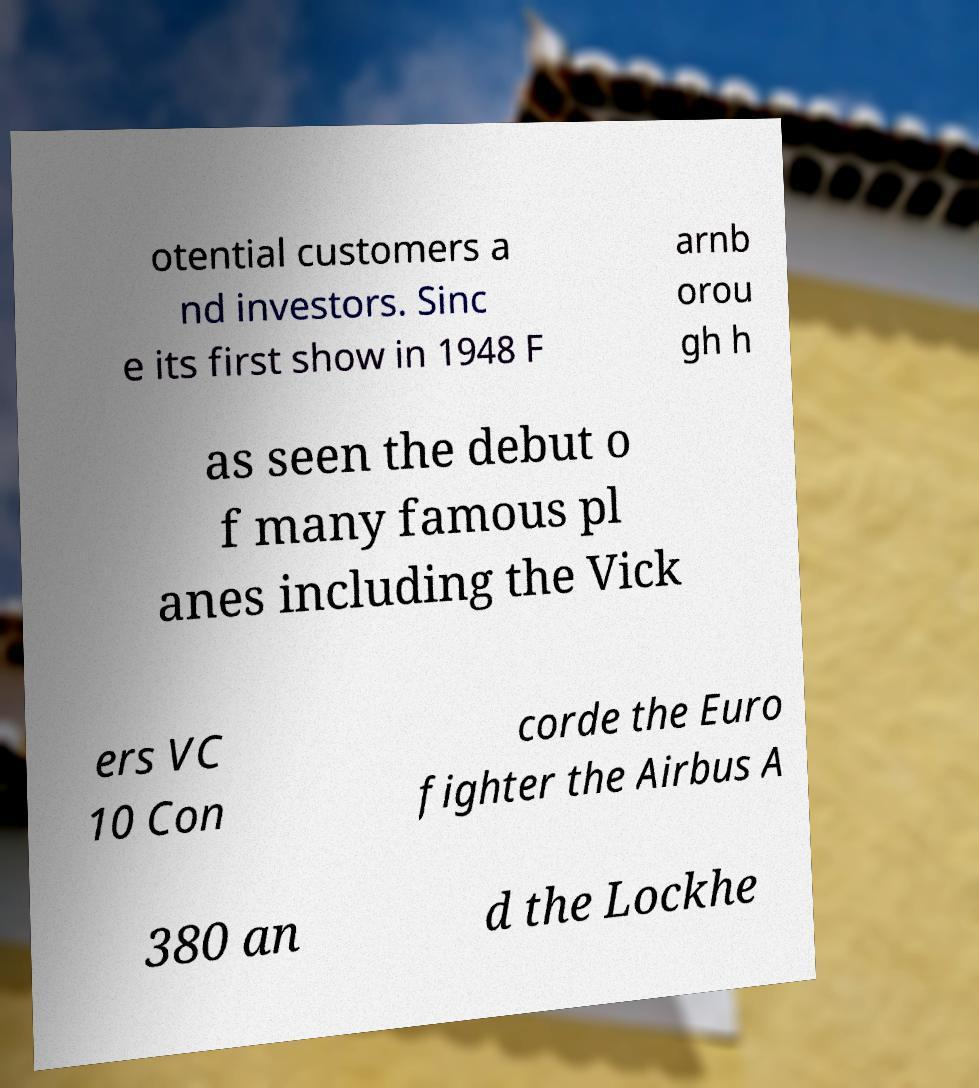Can you read and provide the text displayed in the image?This photo seems to have some interesting text. Can you extract and type it out for me? otential customers a nd investors. Sinc e its first show in 1948 F arnb orou gh h as seen the debut o f many famous pl anes including the Vick ers VC 10 Con corde the Euro fighter the Airbus A 380 an d the Lockhe 